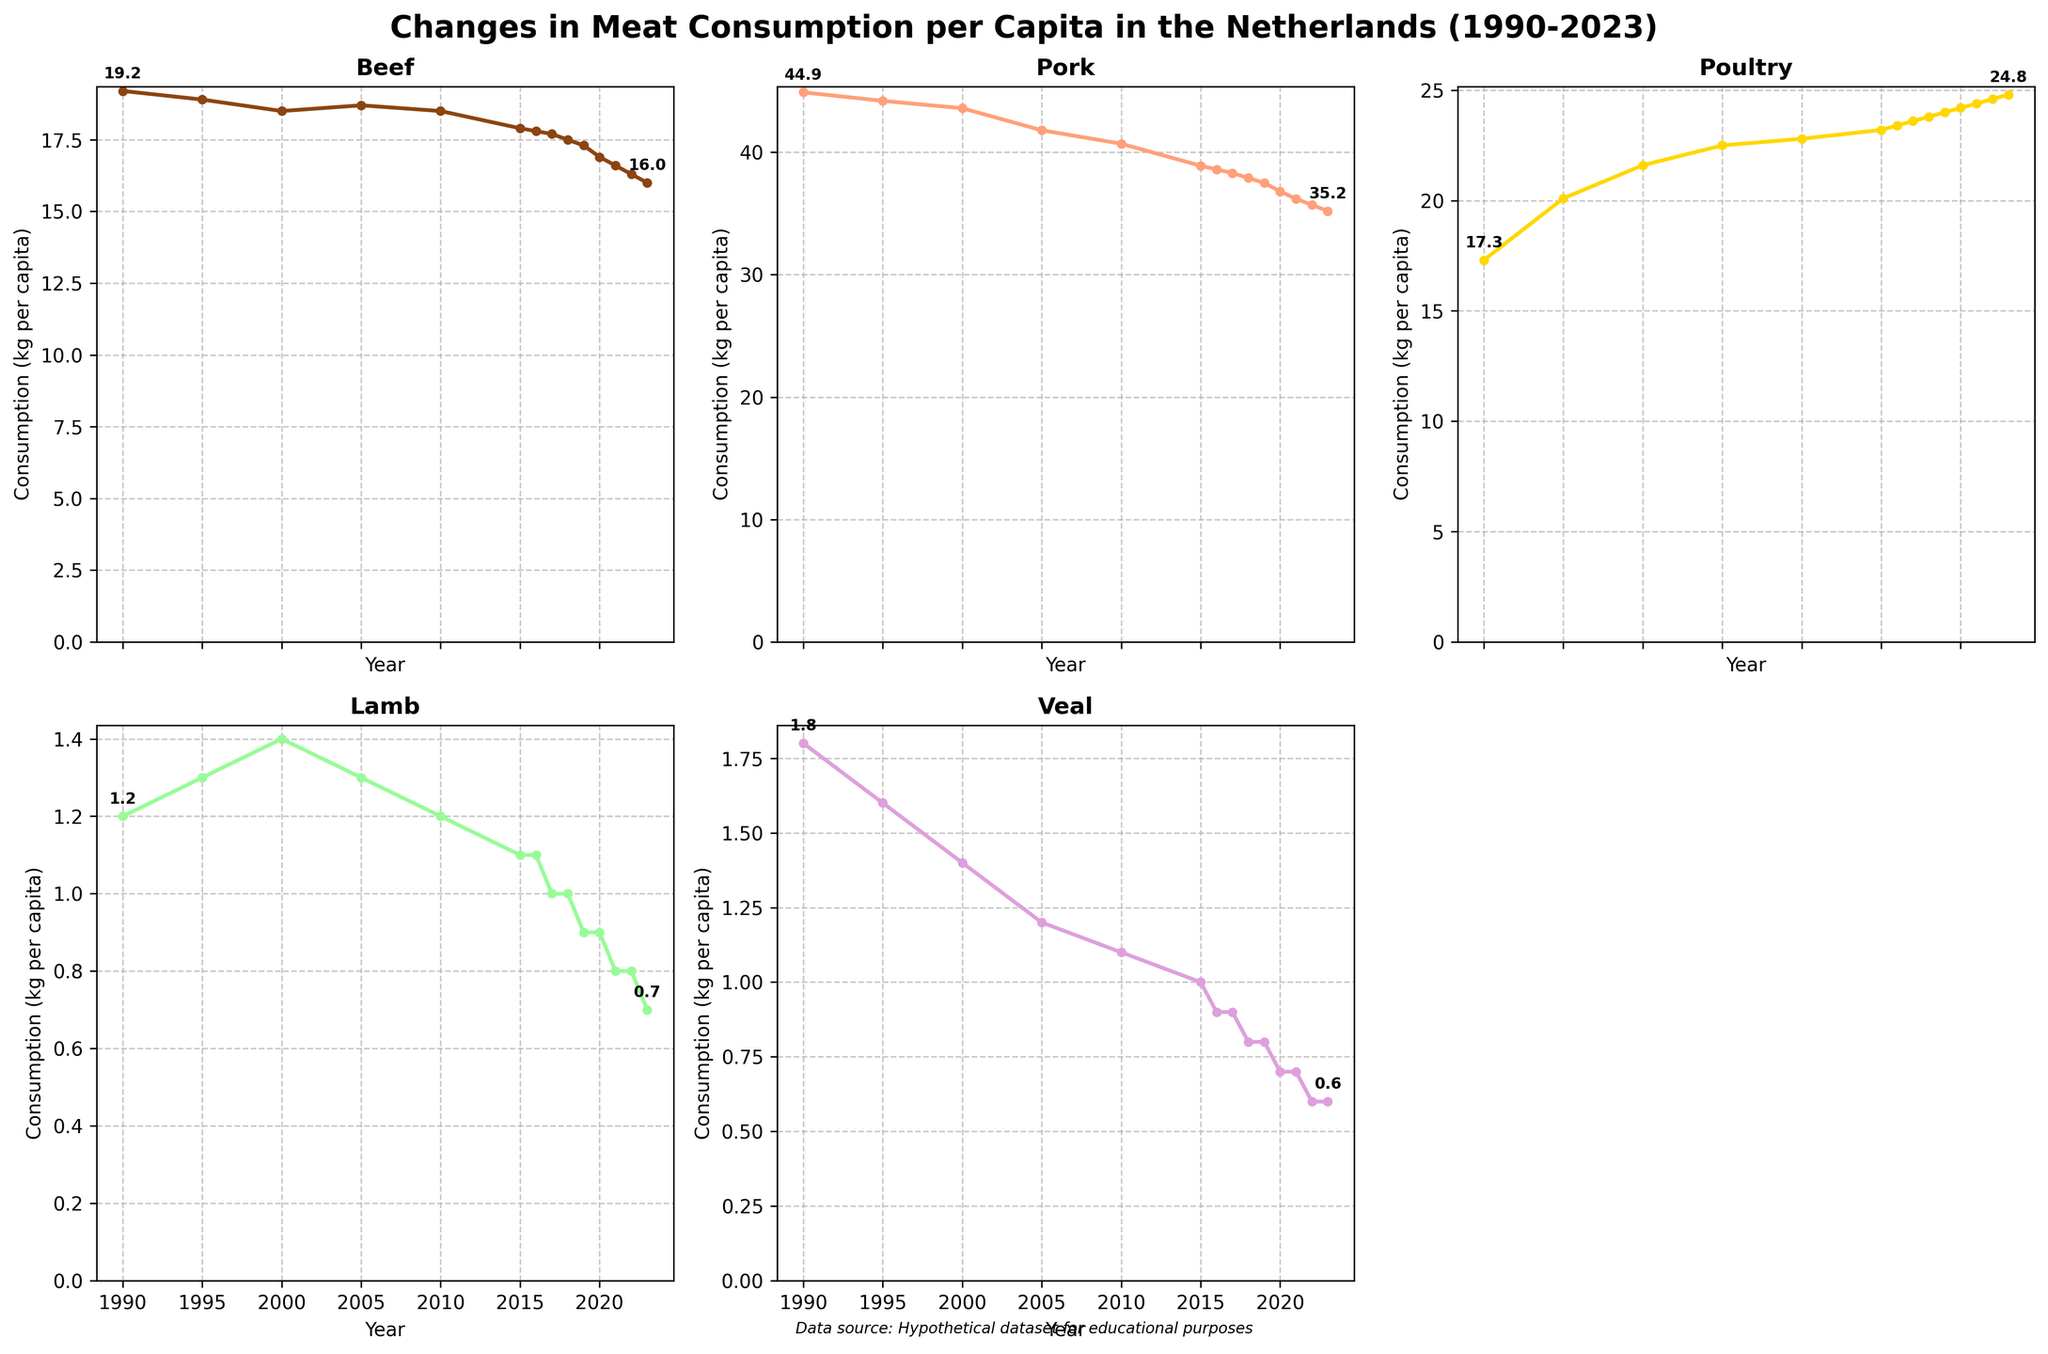What's the consumption trend for poultry from 1990 to 2023? From 1990 to 2023, the poultry consumption per capita has steadily increased. Starting at 17.3 kg per capita in 1990, it reached 24.8 kg per capita by 2023.
Answer: Steady increase Compare the consumption of beef and veal in 1990 and 2023. Which type saw a larger decrease? In 1990, beef consumption was 19.2 kg and veal was 1.8 kg per capita. In 2023, beef consumption was 16.0 kg and veal was 0.6 kg per capita. Beef decreased by 3.2 kg (19.2 - 16.0), while veal decreased by 1.2 kg (1.8 - 0.6).
Answer: Beef Which type of meat has the highest consumption in 2023? By looking at the end values for 2023, the highest consumption is for poultry at 24.8 kg per capita.
Answer: Poultry What is the range of pork consumption between 1990 and 2023? The range is the difference between the highest and lowest consumption values. For pork, it started at 44.9 kg in 1990 and dropped to 35.2 kg in 2023. So, the range is 44.9 - 35.2.
Answer: 9.7 kg Which meat showed a consistent decline from 1990 to 2023? Lamb showed a consistent decline from 1.2 kg per capita in 1990 to 0.7 kg per capita in 2023 without any periods of noticeable increase.
Answer: Lamb Calculate the average consumption of veal from 1990 to 2023. Sum the yearly values for veal: (1.8 + 1.6 + 1.4 + 1.2 + 1.1 + 1.0 + 0.9 + 0.9 + 0.8 + 0.8 + 0.7 + 0.7 + 0.6 + 0.6) = 14.1. There are 14 data points, so 14.1/14.
Answer: 1.0 kg Is there any year where the consumption of pork and poultry was the same? The data shows a declining trend for pork and an increasing trend for poultry. By comparing each year, there is no year where both pork and poultry consumption were the same.
Answer: No Which type of meat has the least variation in consumption over the years? Veal shows the least variation, with values remaining relatively close together and showing a steady decline from 1.8 kg to 0.6 kg per capita.
Answer: Veal How many years did lamb consumption remain the same? Based on the data, lamb consumption was constant at 1.1 kg in 2015 and 2016, and at 1.0 kg in 2017 and 2018, 0.9 kg in 2019 and 2020, and 0.8 kg in 2021 and 2022. So it remained the same for 2 years at each of these levels.
Answer: 6 years 